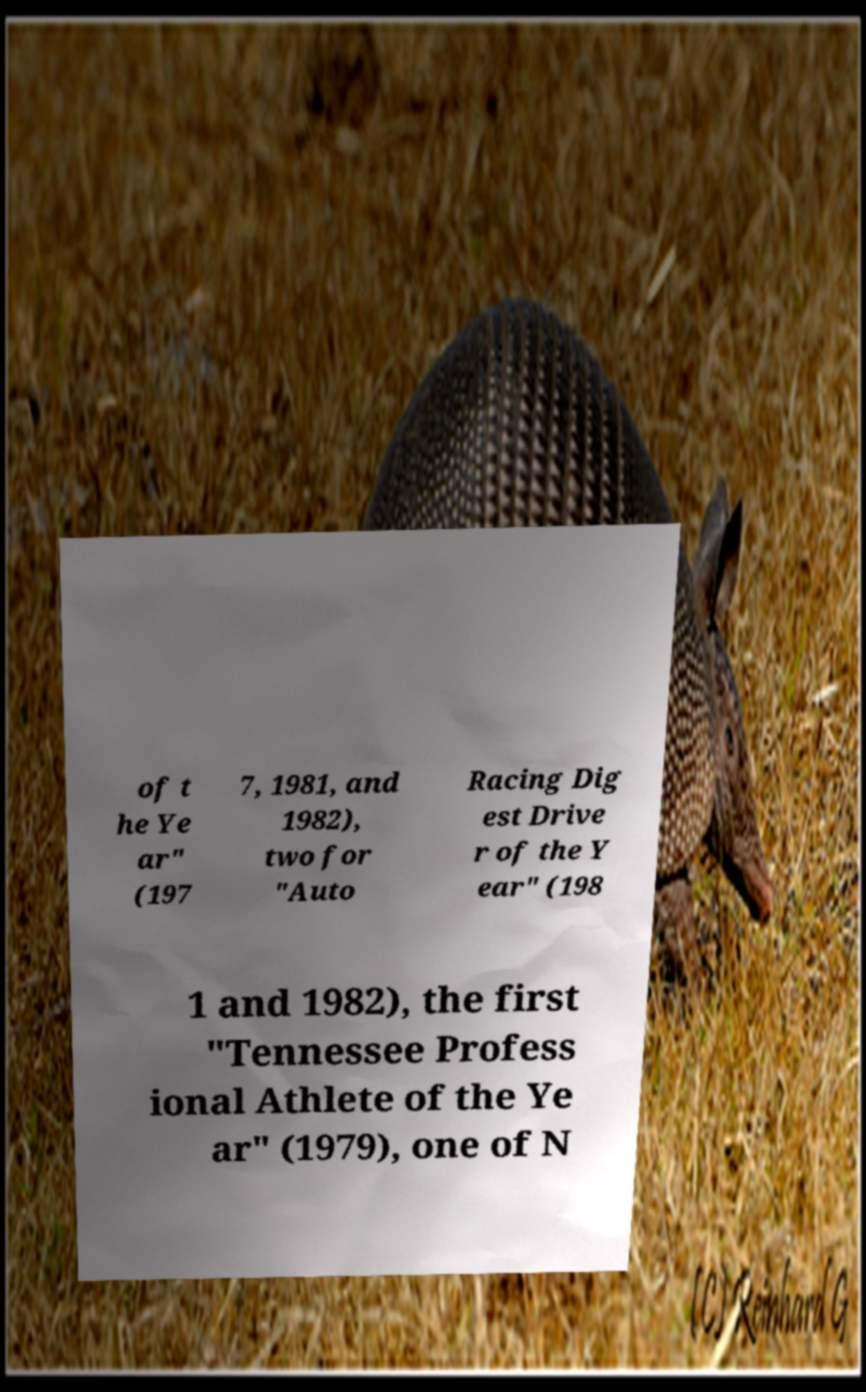I need the written content from this picture converted into text. Can you do that? of t he Ye ar" (197 7, 1981, and 1982), two for "Auto Racing Dig est Drive r of the Y ear" (198 1 and 1982), the first "Tennessee Profess ional Athlete of the Ye ar" (1979), one of N 